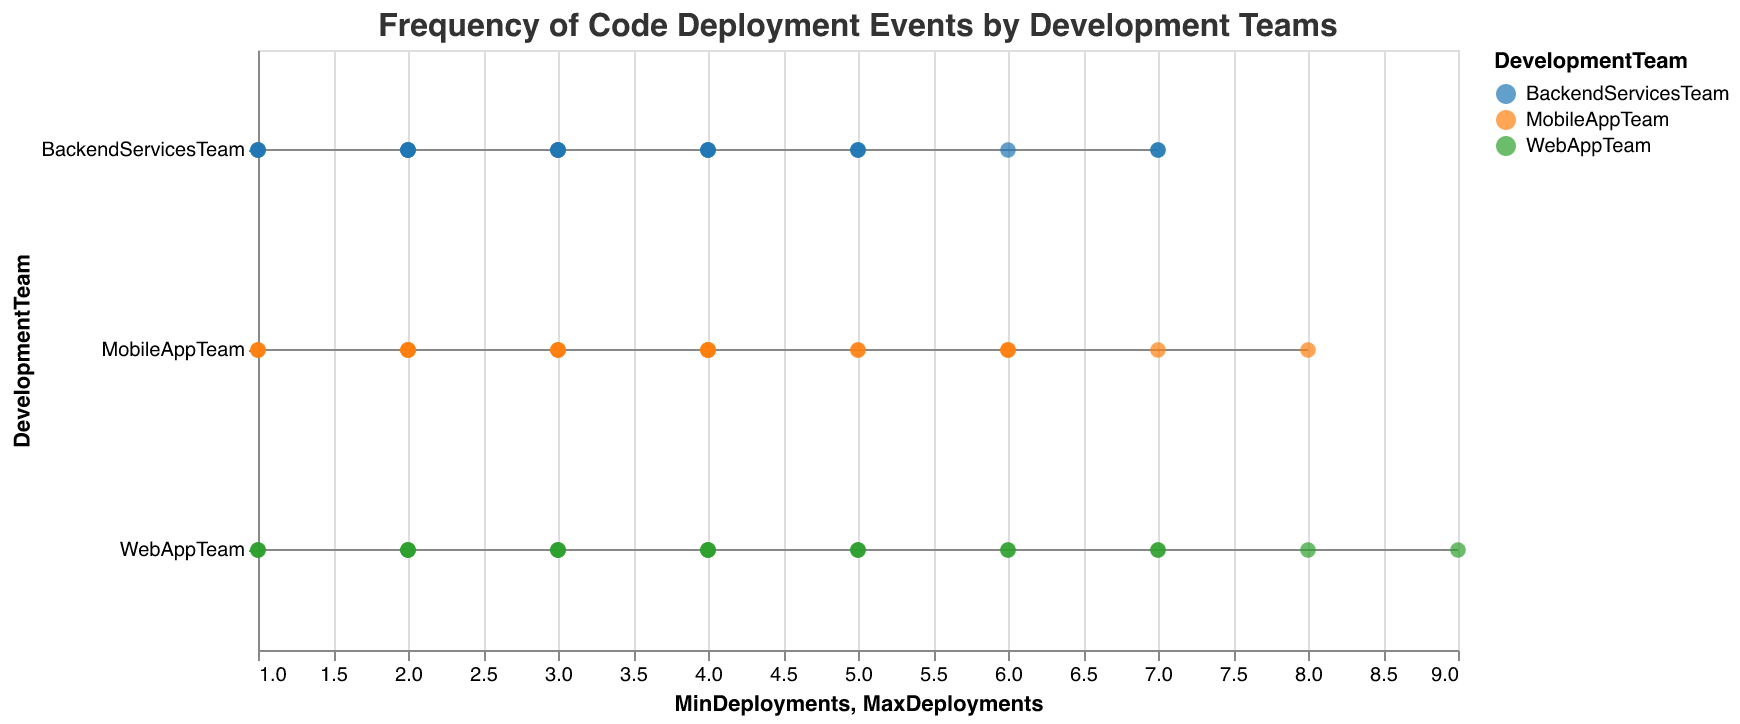Which team had the highest maximum deployments in Week 5? In Week 5, the WebAppTeam had a maximum of 8 deployments, the BackendServicesTeam had 4, and the MobileAppTeam also had 8. By comparing these values, it's clear that both the WebAppTeam and the MobileAppTeam had the highest maximum deployments.
Answer: WebAppTeam and MobileAppTeam What is the range of deployments for the BackendServicesTeam in Week 6? The range is calculated by subtracting the minimum deployments from the maximum deployments. For the BackendServicesTeam in Week 6, the maximum is 7 and the minimum is 3, so the range is 7 - 3 = 4.
Answer: 4 How many weeks did the MobileAppTeam have at least 5 maximum deployments? By examining the figure, we find that the MobileAppTeam had at least 5 maximum deployments in Weeks 1, 4, 5, 9, and 10. Counting these weeks, we get a total of 5 weeks.
Answer: 5 Which team had the most consistent deployment range in Week 11? The consistency of deployment range can be assessed by looking for the smallest range. For Week 11, the WebAppTeam had a range of 3 (5 - 2), BackendServicesTeam had a range of 1 (4 - 3), and the MobileAppTeam had a range of 2 (4 - 2). The smallest range is for the BackendServicesTeam.
Answer: BackendServicesTeam How does the deployment frequency of the WebAppTeam compare between Week 4 and Week 10? In Week 4, the WebAppTeam had a range of 5 deployments (7 - 2). In Week 10, the range was 3 (7 - 4). This shows that the WebAppTeam had a higher range of deployment frequency in Week 4 compared to Week 10.
Answer: Week 4 had a higher range What is the average maximum deployments for the MobileAppTeam across all weeks? Sum the maximum deployments for all weeks and divide by the number of weeks. The maximum deployments are 6, 4, 3, 7, 8, 6, 5, 4, 6, 5, 4, 3. The total is 61. Dividing by 12 weeks, the average is 61 / 12 ≈ 5.08.
Answer: 5.08 In which week did the WebAppTeam have the highest minimum deployments? Examine the figure for the minimum deployments for the WebAppTeam across all weeks: 2, 3, 1, 2, 4, 3, 2, 1, 3, 4, 2, 1. The highest minimum is 4, occurring in Week 10.
Answer: Week 10 